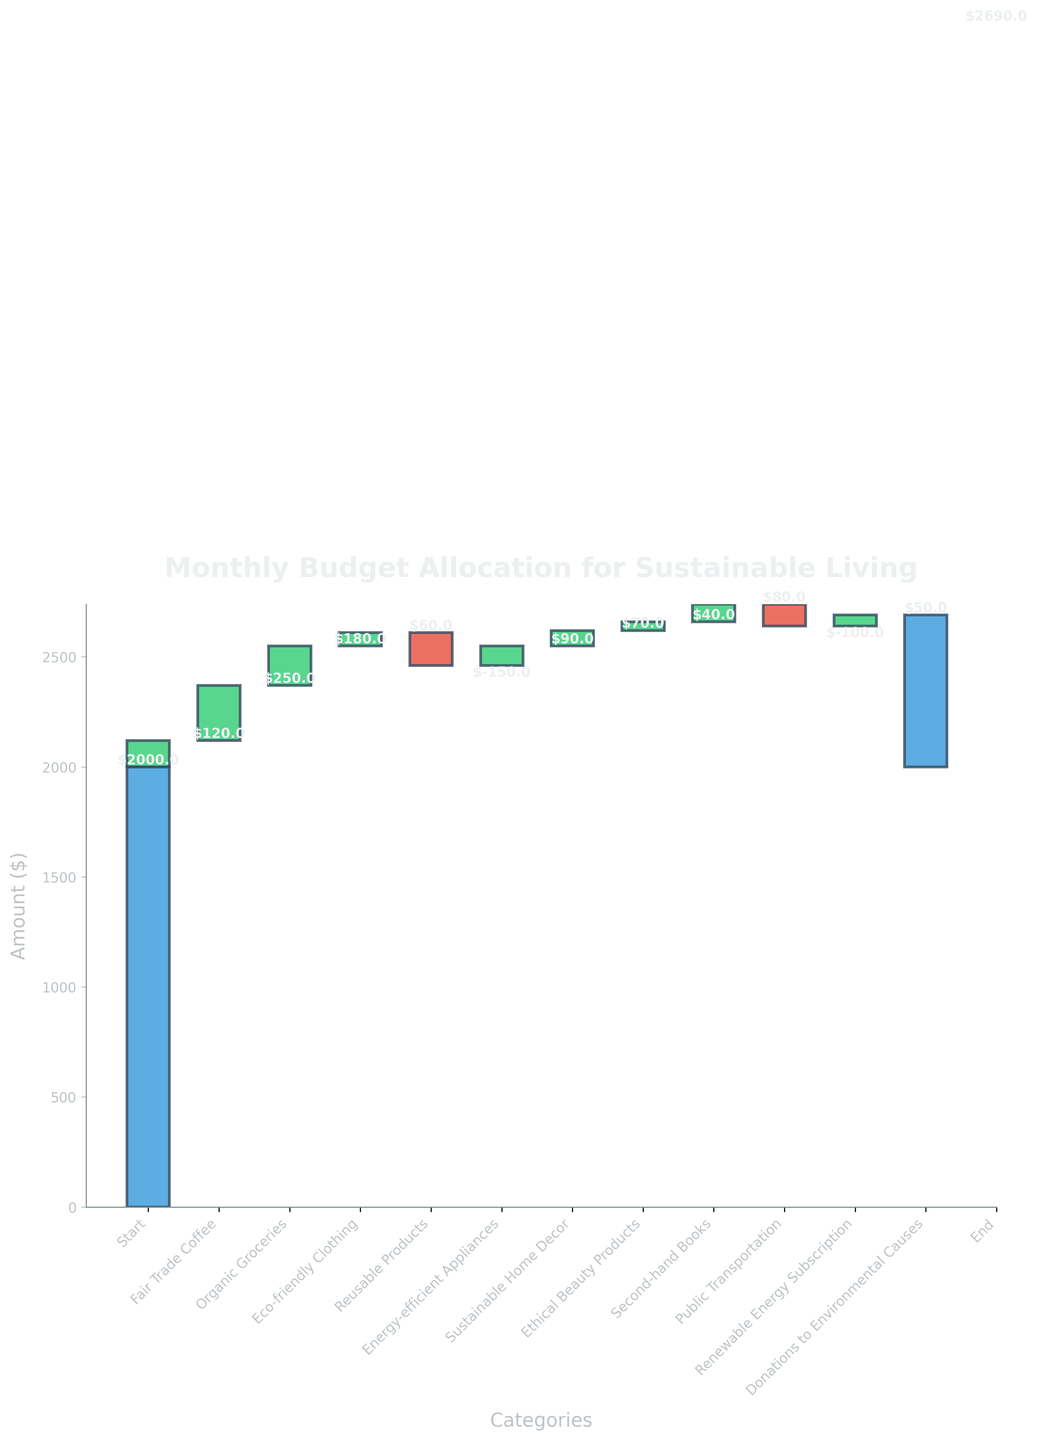what is the title of the chart? The title is found at the top of the chart. It's usually a larger, bold text that describes what the chart represents.
Answer: Monthly Budget Allocation for Sustainable Living what are the categories on the x-axis? The categories on the x-axis are the different labels along the horizontal axis, each representing a different expense type. From left to right, they are: Start, Fair Trade Coffee, Organic Groceries, Eco-friendly Clothing, Reusable Products, Energy-efficient Appliances, Sustainable Home Decor, Ethical Beauty Products, Second-hand Books, Public Transportation, Renewable Energy Subscription, Donations to Environmental Causes, and End.
Answer: Start, Fair Trade Coffee, Organic Groceries, Eco-friendly Clothing, Reusable Products, Energy-efficient Appliances, Sustainable Home Decor, Ethical Beauty Products, Second-hand Books, Public Transportation, Renewable Energy Subscription, Donations to Environmental Causes, End how much is allocated to public transportation? Look for the bar labeled Public Transportation. The value associated with it is shown either on the bar or near it.
Answer: $80 which category has the highest positive allocation? Compare all the positive values indicated along the bars, the highest one will stand out in height. Organic Groceries has the highest allocation of $250.
Answer: Organic Groceries what is the total amount the budget ends with? The End category on the x-axis shows the final cumulative value. The bar in the End category reveals this value which is $690 more than the initial Start value.
Answer: $2690 how much more is spent on eco-friendly clothing compared to reusable products? The value for Eco-friendly Clothing is $180 and for Reusable Products is $60. Subtract the latter from the former. So, $180 - $60.
Answer: $120 which categories have negative allocations and what are their amounts? Identify the bars that drop below the start point or are in red color. They are Energy-efficient Appliances and Renewable Energy Subscription with values -$150 and -$100 respectively.
Answer: Energy-efficient Appliances, Renewable Energy Subscription how much is the net increase in budget from Fair Trade Coffee to Donations? Add up all the positive and negative changes from Fair Trade Coffee to Donations to Environmental Causes. It's $120 + $250 + $180 + $60 - $150 + $90 + $70 + $40 + $80 - $100 + $50.
Answer: $690 how much is the starting budget? The Start category represents the initial budget value. The corresponding value at the start is $2000.
Answer: $2000 what is the relative position of sustainable home decor among other expenses? Check the bar for Sustainable Home Decor and compare its height/value with other positive allocations. It is in the mid-range with $90.
Answer: Mid-range 